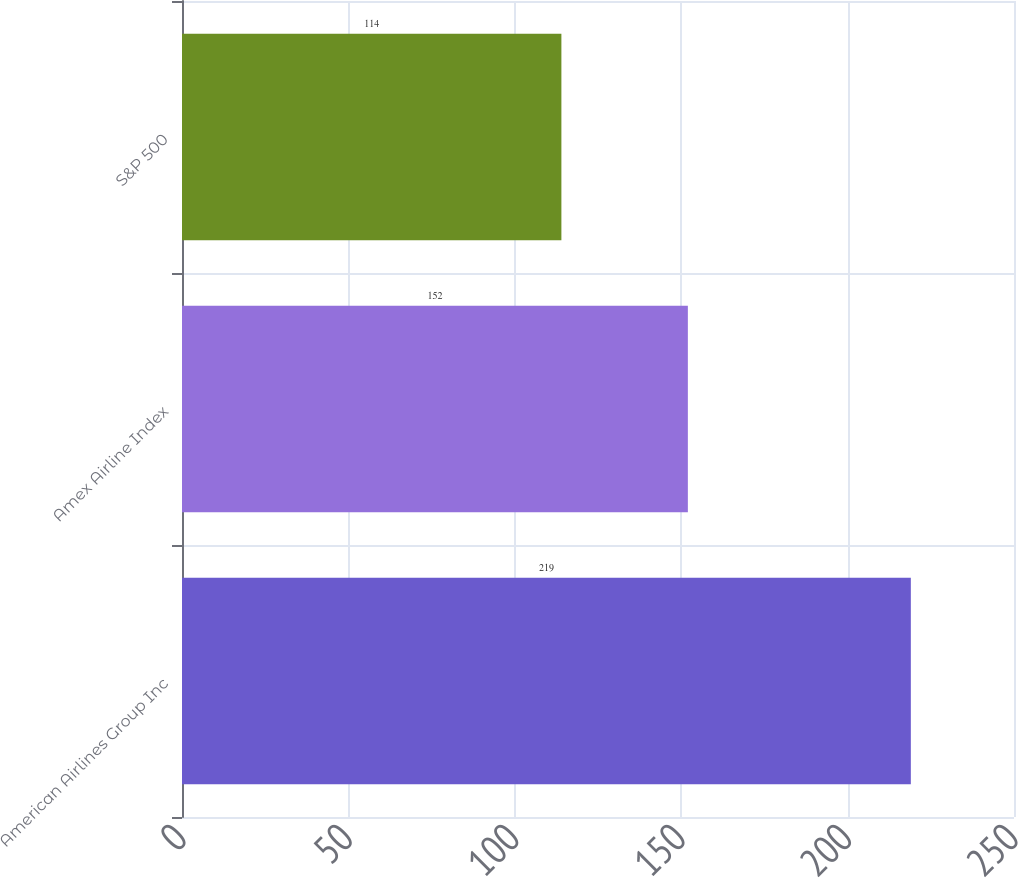Convert chart. <chart><loc_0><loc_0><loc_500><loc_500><bar_chart><fcel>American Airlines Group Inc<fcel>Amex Airline Index<fcel>S&P 500<nl><fcel>219<fcel>152<fcel>114<nl></chart> 